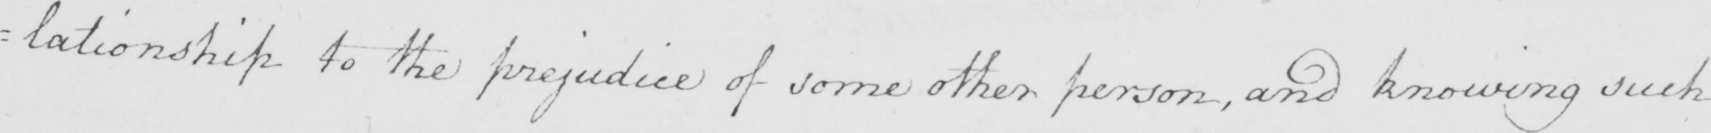What text is written in this handwritten line? =lationship to the prejudice of some other person , and knowing such 